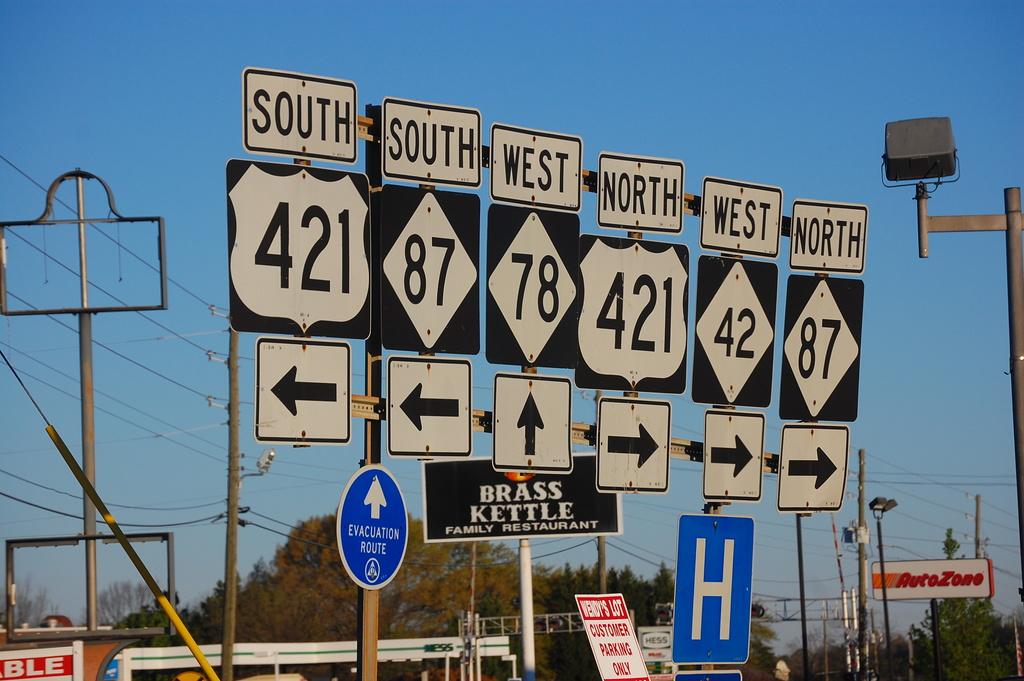Which way do we go to the hospital?
Make the answer very short. West. What is one of the directions mentioned?
Your answer should be very brief. South. 